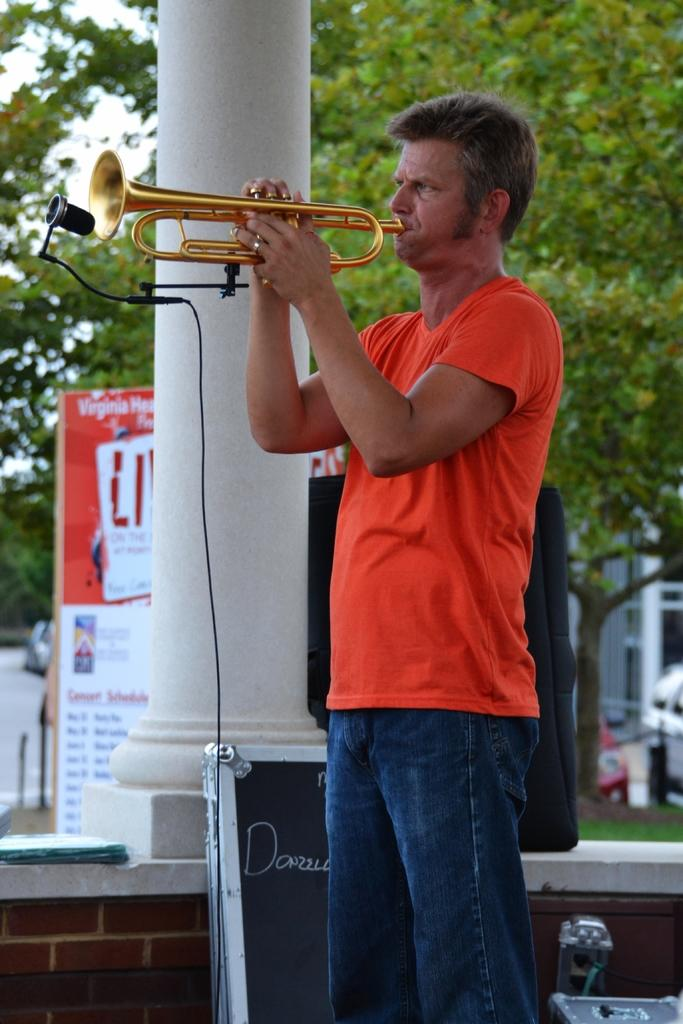What is the man in the image holding? The man is holding a trumpet. What equipment is present for amplifying sound in the image? There is a microphone with a microphone stand and a speaker in the image. What object can be seen for displaying information or messages in the image? There is a board in the image. What type of natural environment is visible in the image? Trees are visible in the image, indicating a natural setting. What part of the sky is visible in the image? The sky is visible in the image, but the specific part is not mentioned. What type of lamp is present on the board in the image? There is no lamp present on the board or in the image. What disease is the man in the image suffering from? There is no indication of any disease in the image, and it is not appropriate to speculate about someone's health based on a photograph. 